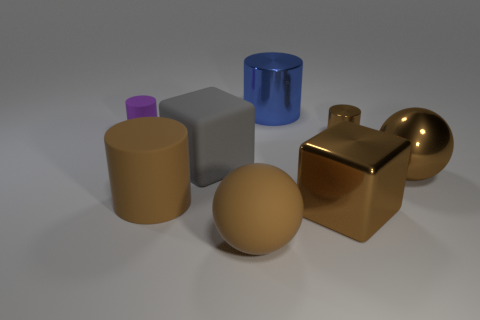Are there an equal number of metallic cubes left of the matte sphere and purple rubber objects?
Ensure brevity in your answer.  No. There is a big ball left of the blue object; is there a brown object that is behind it?
Offer a terse response. Yes. What size is the brown ball on the right side of the big brown sphere on the left side of the large block that is to the right of the large rubber cube?
Your response must be concise. Large. What is the material of the large cube in front of the big ball behind the shiny cube?
Keep it short and to the point. Metal. Is there a tiny brown shiny thing that has the same shape as the purple thing?
Ensure brevity in your answer.  Yes. What is the shape of the gray object?
Keep it short and to the point. Cube. What material is the small cylinder on the right side of the ball that is to the left of the cylinder to the right of the big blue metal object?
Your response must be concise. Metal. Is the number of metallic blocks that are on the left side of the large shiny cylinder greater than the number of big brown metallic spheres?
Ensure brevity in your answer.  No. What material is the blue thing that is the same size as the shiny ball?
Your answer should be very brief. Metal. Is there a brown sphere that has the same size as the purple thing?
Give a very brief answer. No. 